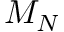Convert formula to latex. <formula><loc_0><loc_0><loc_500><loc_500>M _ { N }</formula> 